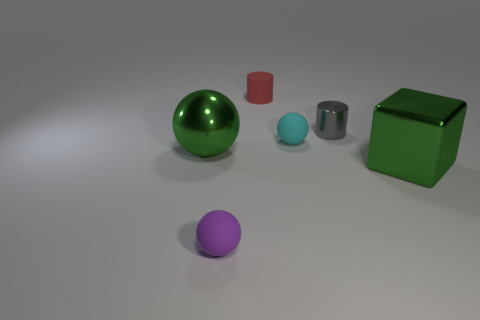There is a small sphere that is to the left of the small cyan matte object that is on the right side of the large green ball; what is it made of?
Your answer should be compact. Rubber. What is the color of the other sphere that is the same material as the cyan sphere?
Provide a short and direct response. Purple. There is a metallic object that is the same color as the cube; what shape is it?
Provide a short and direct response. Sphere. Is the size of the purple sphere left of the tiny gray object the same as the green metallic ball to the left of the big green cube?
Keep it short and to the point. No. What number of cubes are either big green things or tiny cyan things?
Keep it short and to the point. 1. Does the big thing behind the green cube have the same material as the tiny red cylinder?
Your answer should be compact. No. What number of other objects are the same size as the cyan matte ball?
Offer a very short reply. 3. What number of large things are either green things or gray metal cylinders?
Ensure brevity in your answer.  2. Does the big ball have the same color as the big block?
Your response must be concise. Yes. Are there more small matte objects left of the tiny purple rubber thing than small gray things that are right of the gray object?
Your answer should be compact. No. 